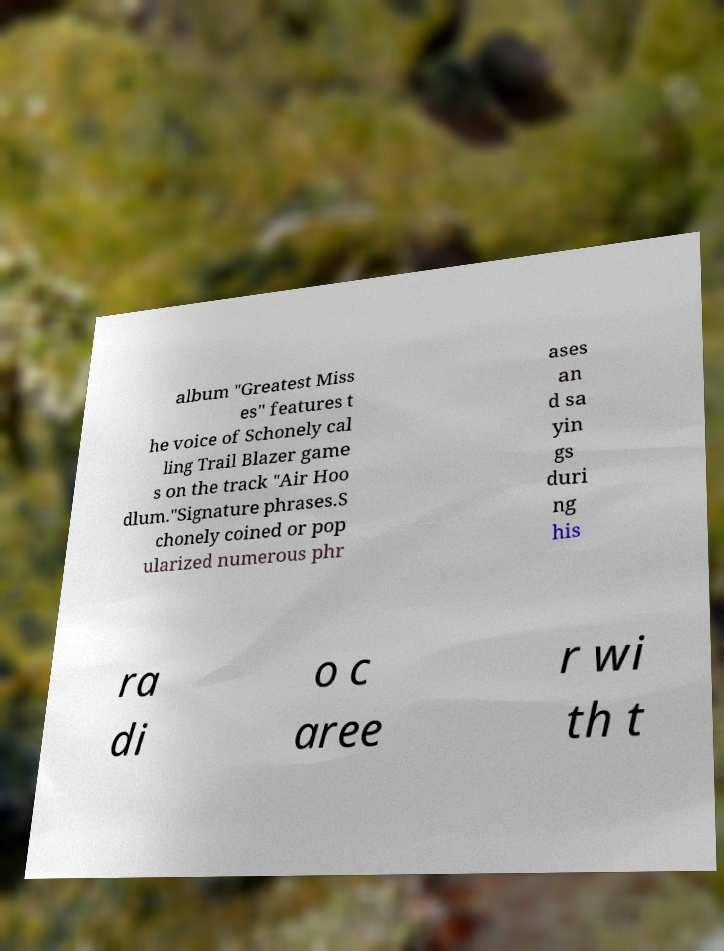Please read and relay the text visible in this image. What does it say? album "Greatest Miss es" features t he voice of Schonely cal ling Trail Blazer game s on the track "Air Hoo dlum."Signature phrases.S chonely coined or pop ularized numerous phr ases an d sa yin gs duri ng his ra di o c aree r wi th t 